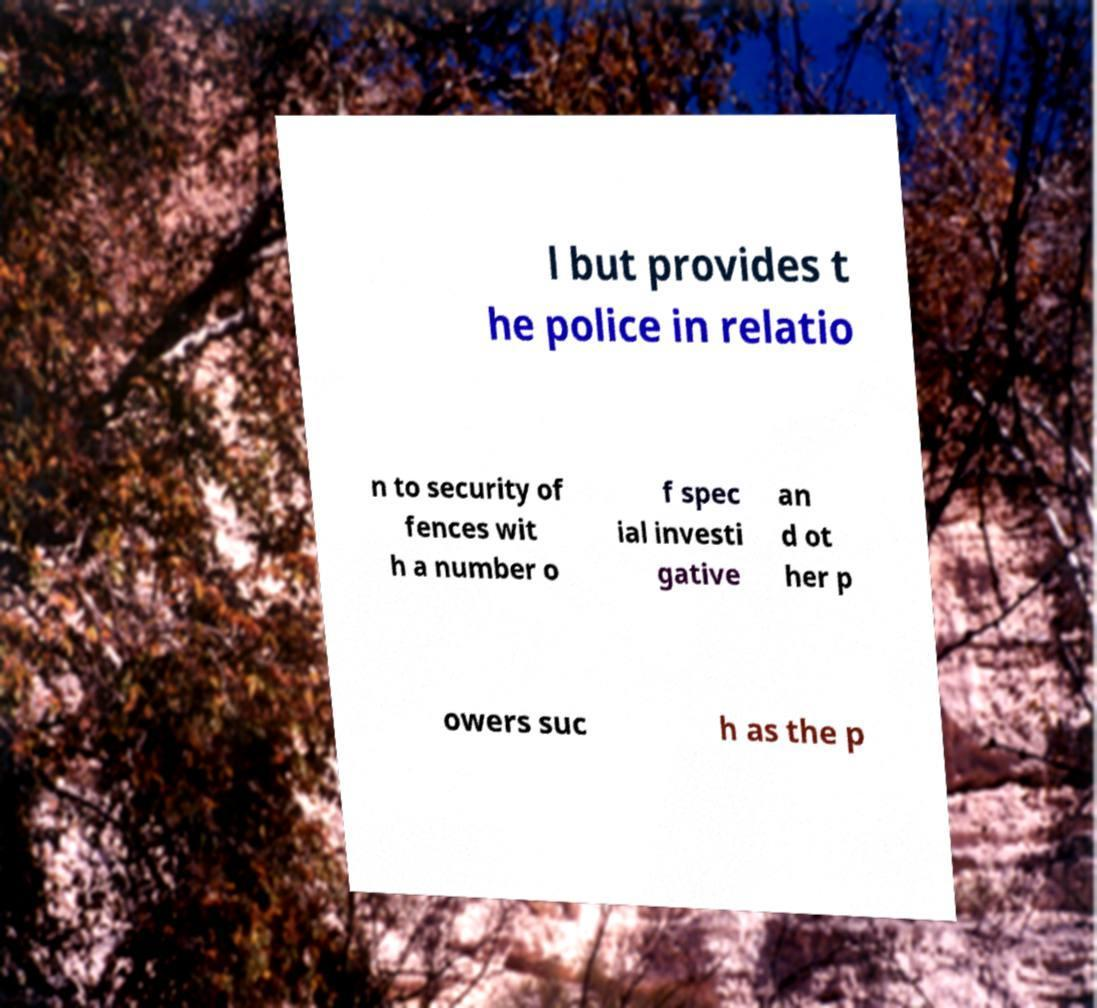Can you read and provide the text displayed in the image?This photo seems to have some interesting text. Can you extract and type it out for me? l but provides t he police in relatio n to security of fences wit h a number o f spec ial investi gative an d ot her p owers suc h as the p 